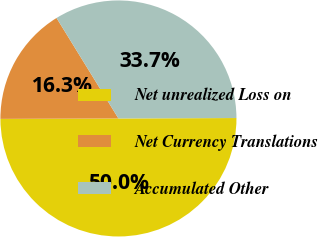Convert chart to OTSL. <chart><loc_0><loc_0><loc_500><loc_500><pie_chart><fcel>Net unrealized Loss on<fcel>Net Currency Translations<fcel>Accumulated Other<nl><fcel>50.0%<fcel>16.27%<fcel>33.73%<nl></chart> 